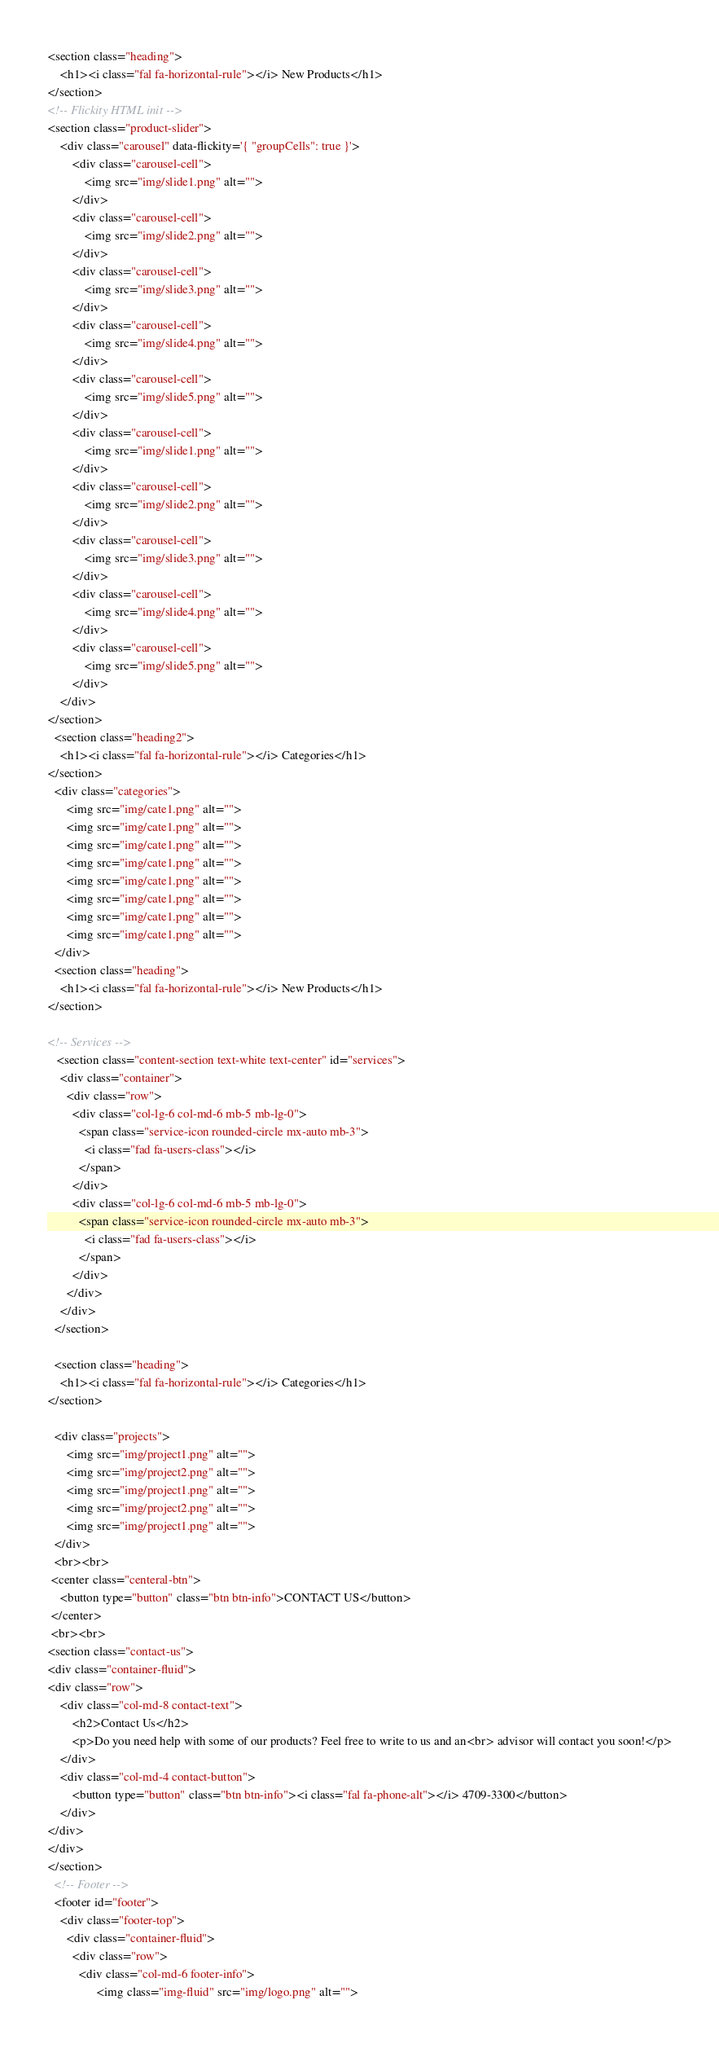<code> <loc_0><loc_0><loc_500><loc_500><_HTML_>
<section class="heading">
    <h1><i class="fal fa-horizontal-rule"></i> New Products</h1>
</section>
<!-- Flickity HTML init -->
<section class="product-slider">
    <div class="carousel" data-flickity='{ "groupCells": true }'>
        <div class="carousel-cell">
            <img src="img/slide1.png" alt="">
        </div>
        <div class="carousel-cell">
            <img src="img/slide2.png" alt="">
        </div>
        <div class="carousel-cell">
            <img src="img/slide3.png" alt="">
        </div>
        <div class="carousel-cell">
            <img src="img/slide4.png" alt="">
        </div>
        <div class="carousel-cell">
            <img src="img/slide5.png" alt="">
        </div>
        <div class="carousel-cell">
            <img src="img/slide1.png" alt="">
        </div>
        <div class="carousel-cell">
            <img src="img/slide2.png" alt="">
        </div>
        <div class="carousel-cell">
            <img src="img/slide3.png" alt="">
        </div>
        <div class="carousel-cell">
            <img src="img/slide4.png" alt="">
        </div>
        <div class="carousel-cell">
            <img src="img/slide5.png" alt="">
        </div>
    </div>
</section>
  <section class="heading2">
    <h1><i class="fal fa-horizontal-rule"></i> Categories</h1>
</section>
  <div class="categories">
      <img src="img/cate1.png" alt="">
      <img src="img/cate1.png" alt="">
      <img src="img/cate1.png" alt="">
      <img src="img/cate1.png" alt="">
      <img src="img/cate1.png" alt="">
      <img src="img/cate1.png" alt="">
      <img src="img/cate1.png" alt="">
      <img src="img/cate1.png" alt="">
  </div>
  <section class="heading">
    <h1><i class="fal fa-horizontal-rule"></i> New Products</h1>
</section>

<!-- Services -->
   <section class="content-section text-white text-center" id="services">
    <div class="container">
      <div class="row">
        <div class="col-lg-6 col-md-6 mb-5 mb-lg-0">
          <span class="service-icon rounded-circle mx-auto mb-3">
            <i class="fad fa-users-class"></i>
          </span>
        </div>
        <div class="col-lg-6 col-md-6 mb-5 mb-lg-0">
          <span class="service-icon rounded-circle mx-auto mb-3">
            <i class="fad fa-users-class"></i>
          </span>
        </div>
      </div>
    </div>
  </section>

  <section class="heading">
    <h1><i class="fal fa-horizontal-rule"></i> Categories</h1>
</section>

  <div class="projects">
      <img src="img/project1.png" alt="">
      <img src="img/project2.png" alt="">
      <img src="img/project1.png" alt="">
      <img src="img/project2.png" alt="">
      <img src="img/project1.png" alt="">
  </div>
  <br><br>
 <center class="centeral-btn">
    <button type="button" class="btn btn-info">CONTACT US</button>
 </center>
 <br><br>
<section class="contact-us">
<div class="container-fluid">
<div class="row">
    <div class="col-md-8 contact-text">
        <h2>Contact Us</h2>
        <p>Do you need help with some of our products? Feel free to write to us and an<br> advisor will contact you soon!</p>
    </div>
    <div class="col-md-4 contact-button">
        <button type="button" class="btn btn-info"><i class="fal fa-phone-alt"></i> 4709-3300</button>
    </div>
</div>
</div>
</section>
  <!-- Footer -->
  <footer id="footer">
    <div class="footer-top">
      <div class="container-fluid">
        <div class="row">
          <div class="col-md-6 footer-info">
                <img class="img-fluid" src="img/logo.png" alt=""></code> 